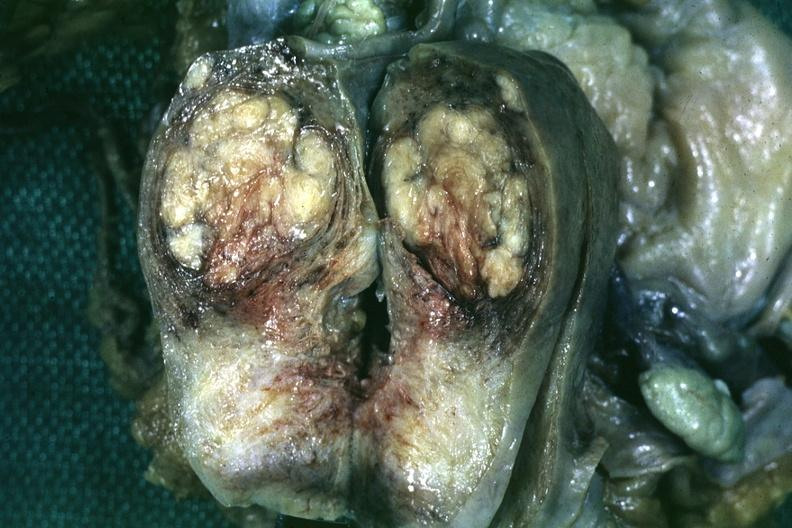s sacrococcygeal teratoma present?
Answer the question using a single word or phrase. No 